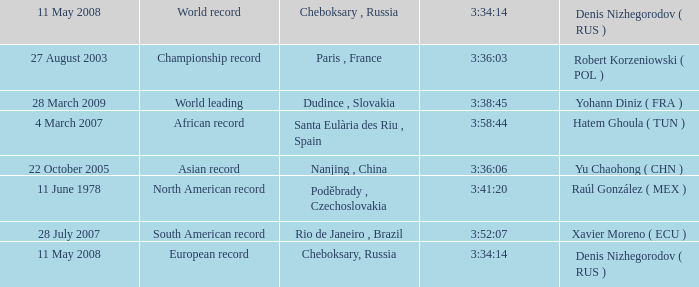When 3:38:45 is  3:34:14 what is the date on May 11th, 2008? 28 March 2009. 